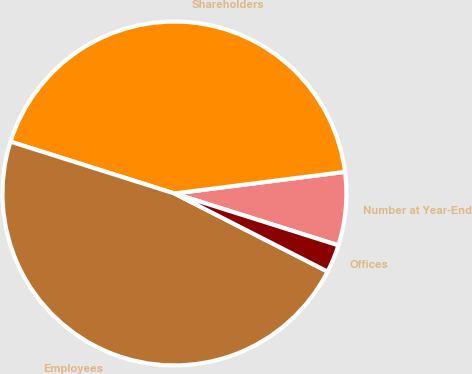Convert chart. <chart><loc_0><loc_0><loc_500><loc_500><pie_chart><fcel>Number at Year-End<fcel>Shareholders<fcel>Employees<fcel>Offices<nl><fcel>6.88%<fcel>43.12%<fcel>47.37%<fcel>2.63%<nl></chart> 